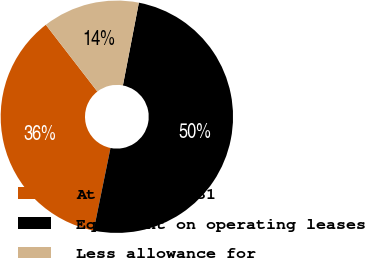Convert chart to OTSL. <chart><loc_0><loc_0><loc_500><loc_500><pie_chart><fcel>At December 31<fcel>Equipment on operating leases<fcel>Less allowance for<nl><fcel>36.33%<fcel>50.17%<fcel>13.5%<nl></chart> 